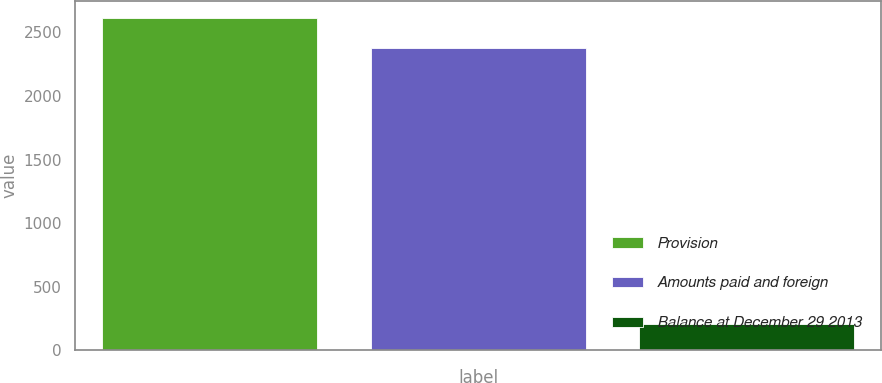Convert chart to OTSL. <chart><loc_0><loc_0><loc_500><loc_500><bar_chart><fcel>Provision<fcel>Amounts paid and foreign<fcel>Balance at December 29 2013<nl><fcel>2614.7<fcel>2377<fcel>208<nl></chart> 